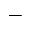<formula> <loc_0><loc_0><loc_500><loc_500>\_</formula> 